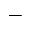<formula> <loc_0><loc_0><loc_500><loc_500>\_</formula> 